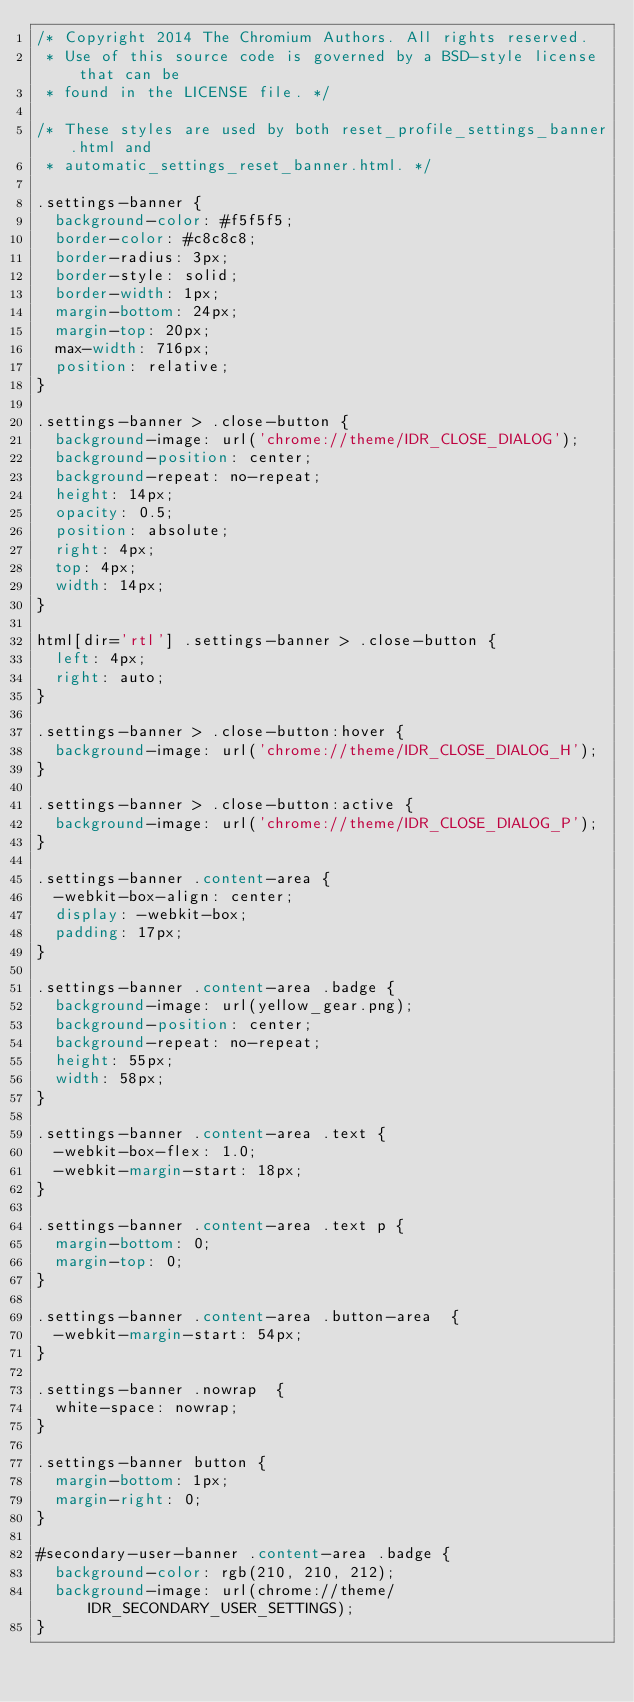<code> <loc_0><loc_0><loc_500><loc_500><_CSS_>/* Copyright 2014 The Chromium Authors. All rights reserved.
 * Use of this source code is governed by a BSD-style license that can be
 * found in the LICENSE file. */

/* These styles are used by both reset_profile_settings_banner.html and
 * automatic_settings_reset_banner.html. */

.settings-banner {
  background-color: #f5f5f5;
  border-color: #c8c8c8;
  border-radius: 3px;
  border-style: solid;
  border-width: 1px;
  margin-bottom: 24px;
  margin-top: 20px;
  max-width: 716px;
  position: relative;
}

.settings-banner > .close-button {
  background-image: url('chrome://theme/IDR_CLOSE_DIALOG');
  background-position: center;
  background-repeat: no-repeat;
  height: 14px;
  opacity: 0.5;
  position: absolute;
  right: 4px;
  top: 4px;
  width: 14px;
}

html[dir='rtl'] .settings-banner > .close-button {
  left: 4px;
  right: auto;
}

.settings-banner > .close-button:hover {
  background-image: url('chrome://theme/IDR_CLOSE_DIALOG_H');
}

.settings-banner > .close-button:active {
  background-image: url('chrome://theme/IDR_CLOSE_DIALOG_P');
}

.settings-banner .content-area {
  -webkit-box-align: center;
  display: -webkit-box;
  padding: 17px;
}

.settings-banner .content-area .badge {
  background-image: url(yellow_gear.png);
  background-position: center;
  background-repeat: no-repeat;
  height: 55px;
  width: 58px;
}

.settings-banner .content-area .text {
  -webkit-box-flex: 1.0;
  -webkit-margin-start: 18px;
}

.settings-banner .content-area .text p {
  margin-bottom: 0;
  margin-top: 0;
}

.settings-banner .content-area .button-area  {
  -webkit-margin-start: 54px;
}

.settings-banner .nowrap  {
  white-space: nowrap;
}

.settings-banner button {
  margin-bottom: 1px;
  margin-right: 0;
}

#secondary-user-banner .content-area .badge {
  background-color: rgb(210, 210, 212);
  background-image: url(chrome://theme/IDR_SECONDARY_USER_SETTINGS);
}
</code> 